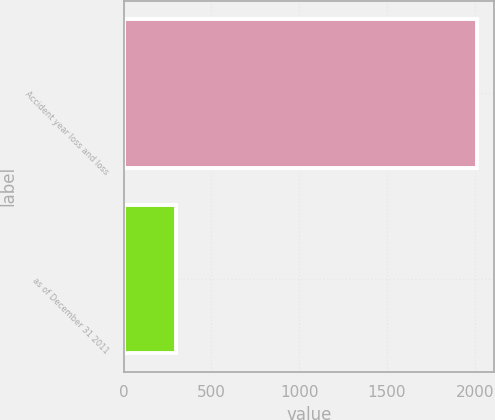<chart> <loc_0><loc_0><loc_500><loc_500><bar_chart><fcel>Accident year loss and loss<fcel>as of December 31 2011<nl><fcel>2011<fcel>301<nl></chart> 